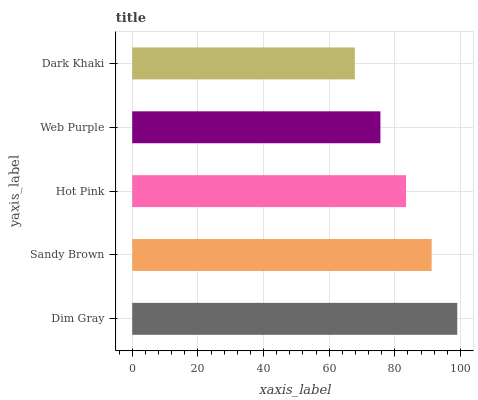Is Dark Khaki the minimum?
Answer yes or no. Yes. Is Dim Gray the maximum?
Answer yes or no. Yes. Is Sandy Brown the minimum?
Answer yes or no. No. Is Sandy Brown the maximum?
Answer yes or no. No. Is Dim Gray greater than Sandy Brown?
Answer yes or no. Yes. Is Sandy Brown less than Dim Gray?
Answer yes or no. Yes. Is Sandy Brown greater than Dim Gray?
Answer yes or no. No. Is Dim Gray less than Sandy Brown?
Answer yes or no. No. Is Hot Pink the high median?
Answer yes or no. Yes. Is Hot Pink the low median?
Answer yes or no. Yes. Is Sandy Brown the high median?
Answer yes or no. No. Is Dim Gray the low median?
Answer yes or no. No. 